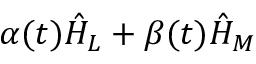<formula> <loc_0><loc_0><loc_500><loc_500>\alpha ( t ) \hat { H } _ { L } + \beta ( t ) \hat { H } _ { M }</formula> 